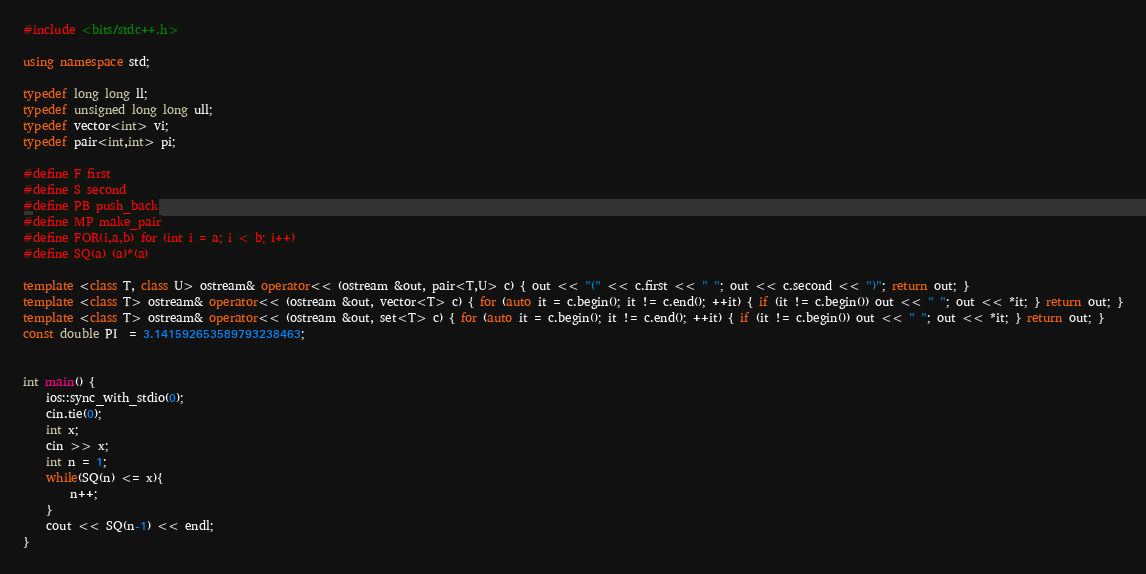<code> <loc_0><loc_0><loc_500><loc_500><_C++_>#include <bits/stdc++.h>

using namespace std;

typedef long long ll;
typedef unsigned long long ull; 
typedef vector<int> vi;
typedef pair<int,int> pi;

#define F first
#define S second
#define PB push_back
#define MP make_pair
#define FOR(i,a,b) for (int i = a; i < b; i++)
#define SQ(a) (a)*(a)

template <class T, class U> ostream& operator<< (ostream &out, pair<T,U> c) { out << "(" << c.first << " "; out << c.second << ")"; return out; }
template <class T> ostream& operator<< (ostream &out, vector<T> c) { for (auto it = c.begin(); it != c.end(); ++it) { if (it != c.begin()) out << " "; out << *it; } return out; }
template <class T> ostream& operator<< (ostream &out, set<T> c) { for (auto it = c.begin(); it != c.end(); ++it) { if (it != c.begin()) out << " "; out << *it; } return out; }
const double PI  = 3.141592653589793238463;


int main() {
    ios::sync_with_stdio(0);
    cin.tie(0);
    int x;
    cin >> x;
    int n = 1;
    while(SQ(n) <= x){
        n++;
    }
    cout << SQ(n-1) << endl;
}   </code> 